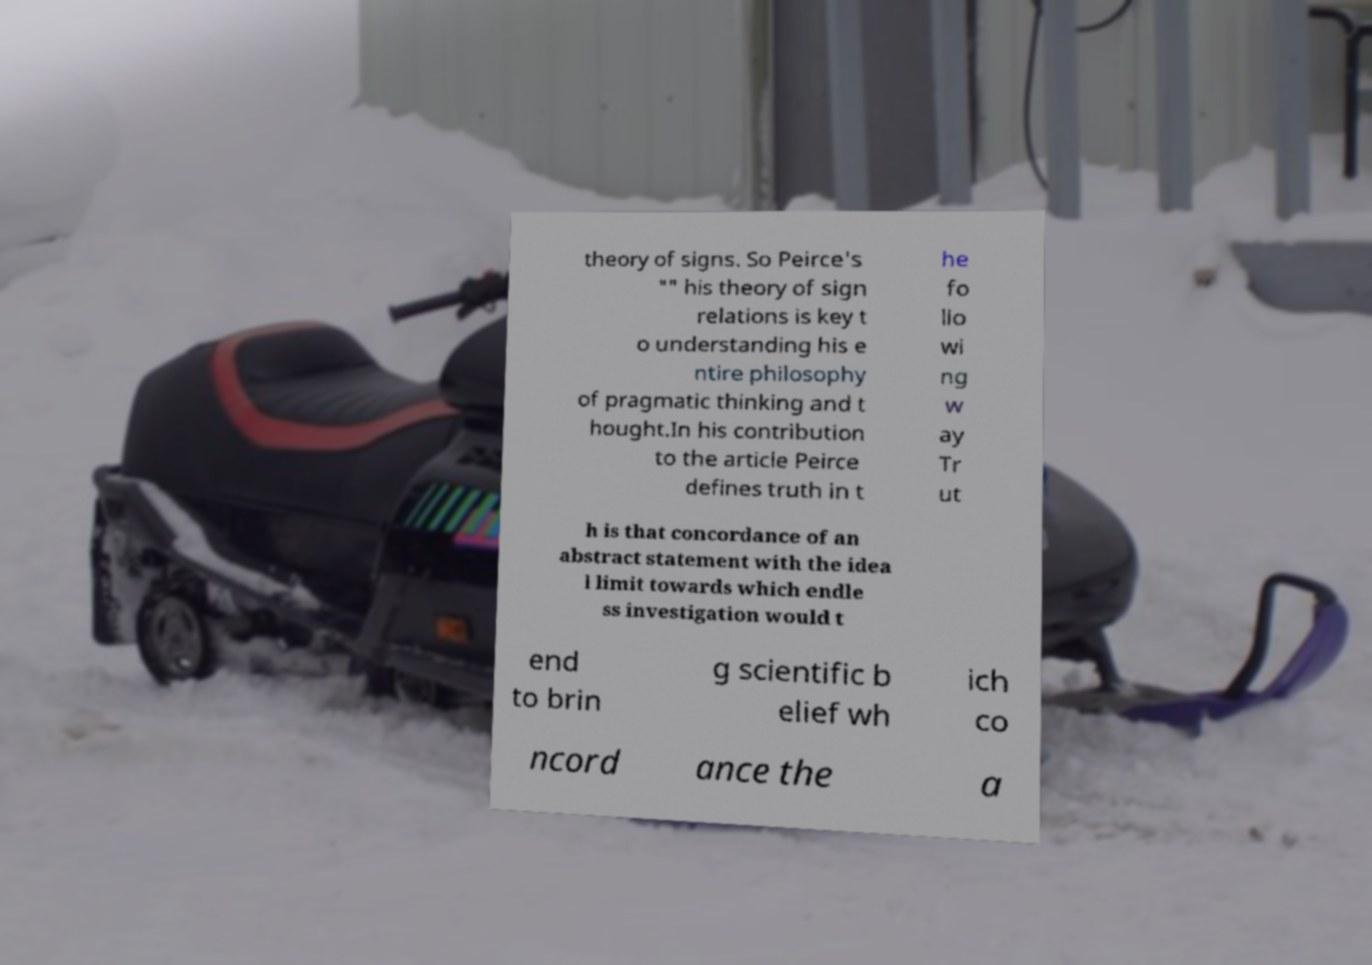For documentation purposes, I need the text within this image transcribed. Could you provide that? theory of signs. So Peirce's "" his theory of sign relations is key t o understanding his e ntire philosophy of pragmatic thinking and t hought.In his contribution to the article Peirce defines truth in t he fo llo wi ng w ay Tr ut h is that concordance of an abstract statement with the idea l limit towards which endle ss investigation would t end to brin g scientific b elief wh ich co ncord ance the a 